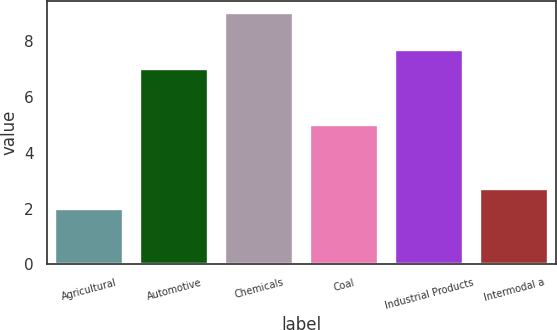<chart> <loc_0><loc_0><loc_500><loc_500><bar_chart><fcel>Agricultural<fcel>Automotive<fcel>Chemicals<fcel>Coal<fcel>Industrial Products<fcel>Intermodal a<nl><fcel>2<fcel>7<fcel>9<fcel>5<fcel>7.7<fcel>2.7<nl></chart> 